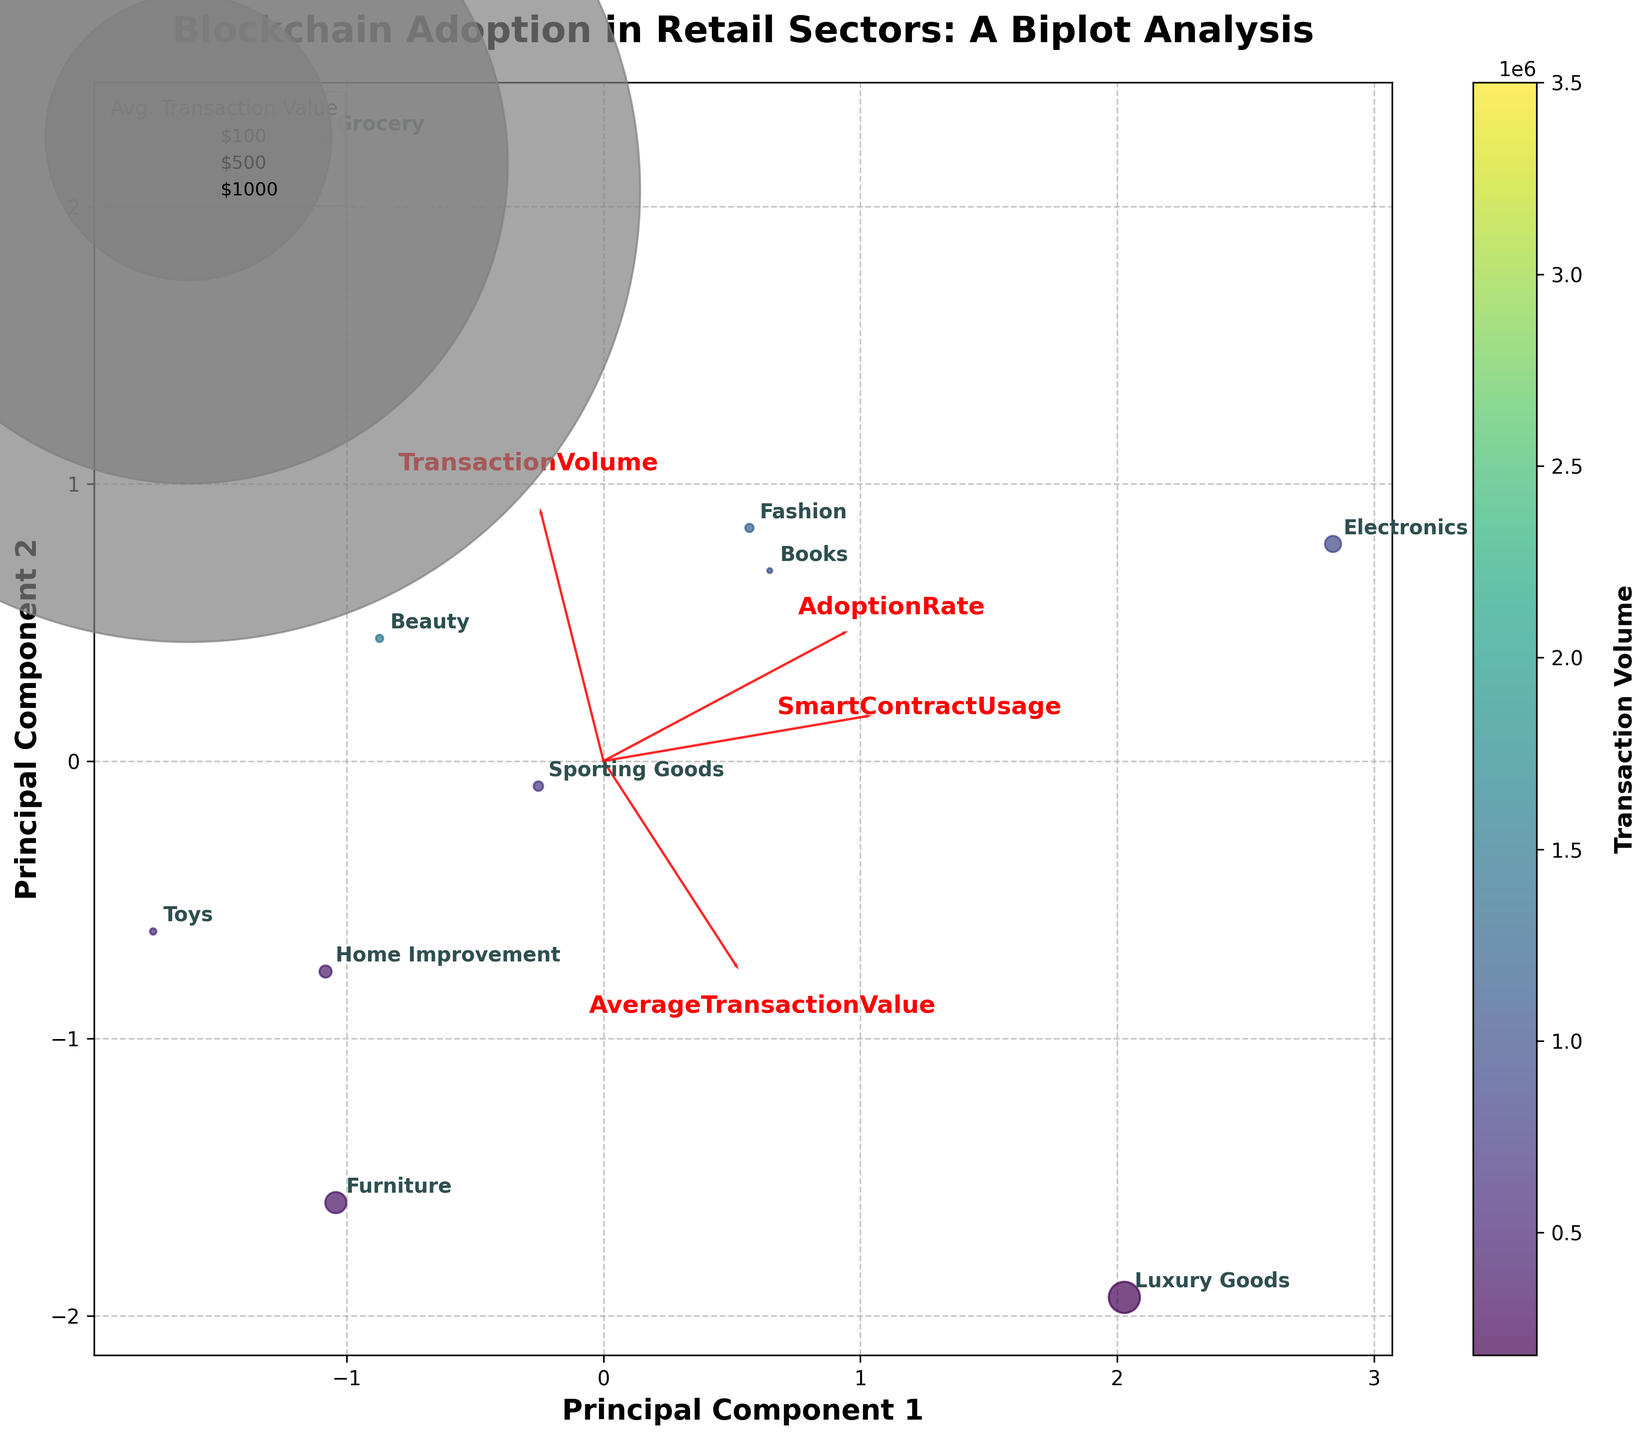What's the title of the biplot? The title of the biplot is visually displayed at the top of the figure.
Answer: Blockchain Adoption in Retail Sectors: A Biplot Analysis Which sector has the highest blockchain adoption rate? From the biplot, the sector with the highest blockchain adoption rate will be located furthest along the relevant principal component (PC1 or PC2) in the positive direction corresponding to the "AdoptionRate" loading vector (red arrow).
Answer: Electronics Which feature has the longest loading vector? By visually comparing all the red arrows (loading vectors), the feature with the arrow extending the furthest from the origin has the longest loading vector.
Answer: TransactionVolume How are Fashion and Books positioned relative to each other? Looking at the positions of these two sectors on the figure, compare their coordinates. Specifically, note their placement along the principal components axes.
Answer: Fashion and Books are close to each other What is the relationship between TransactionVolume and SmartContractUsage? Observe the directions and lengths of the red arrows for "TransactionVolume" and "SmartContractUsage." If they are in similar directions and have similar lengths, they are positively correlated.
Answer: They appear to be positively correlated Which sector is closest to the origin of the plot? By examining the distances from the origin (0,0) to the data points, the sector physically closest to this point on the plot can be identified.
Answer: Toys Which feature seems to explain the most variance in the second principal component? Check the length and direction of the red arrows along the PC2 axis; the longer arrows along PC2 explain more variance.
Answer: SmartContractUsage Is there a visible correlation between AdoptionRate and AverageTransactionValue? Look at the direction of the loading vectors for "AdoptionRate" and "AverageTransactionValue." If they point in similar or opposite directions, there is a correlation.
Answer: No strong visible correlation Which sector has the highest TransactionVolume with a corresponding lower AdoptionRate? Identify the sector represented by the data point with a high colorbar value (TransactionVolume) but positioned lower along the "AdoptionRate" axis.
Answer: Grocery What trend is indicated by the gradient of colors in the scatter plot? The gradient of colors in the scatter plot, represented by the colorbar from lighter to darker shades, indicates the distribution of TransactionVolume values across sectors. Darker colors represent higher transaction volumes.
Answer: Higher transaction volumes are generally associated with lower AdoptionRates 